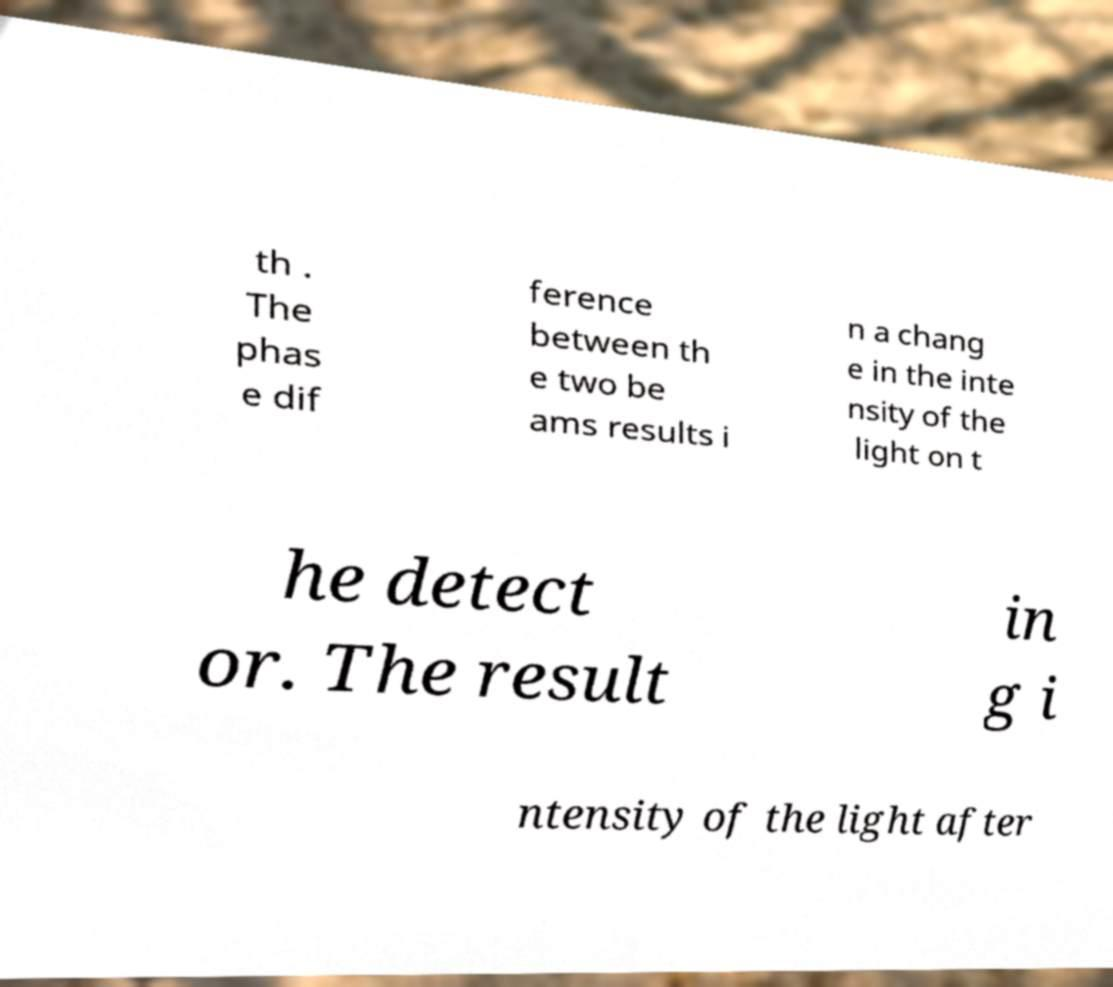Can you read and provide the text displayed in the image?This photo seems to have some interesting text. Can you extract and type it out for me? th . The phas e dif ference between th e two be ams results i n a chang e in the inte nsity of the light on t he detect or. The result in g i ntensity of the light after 